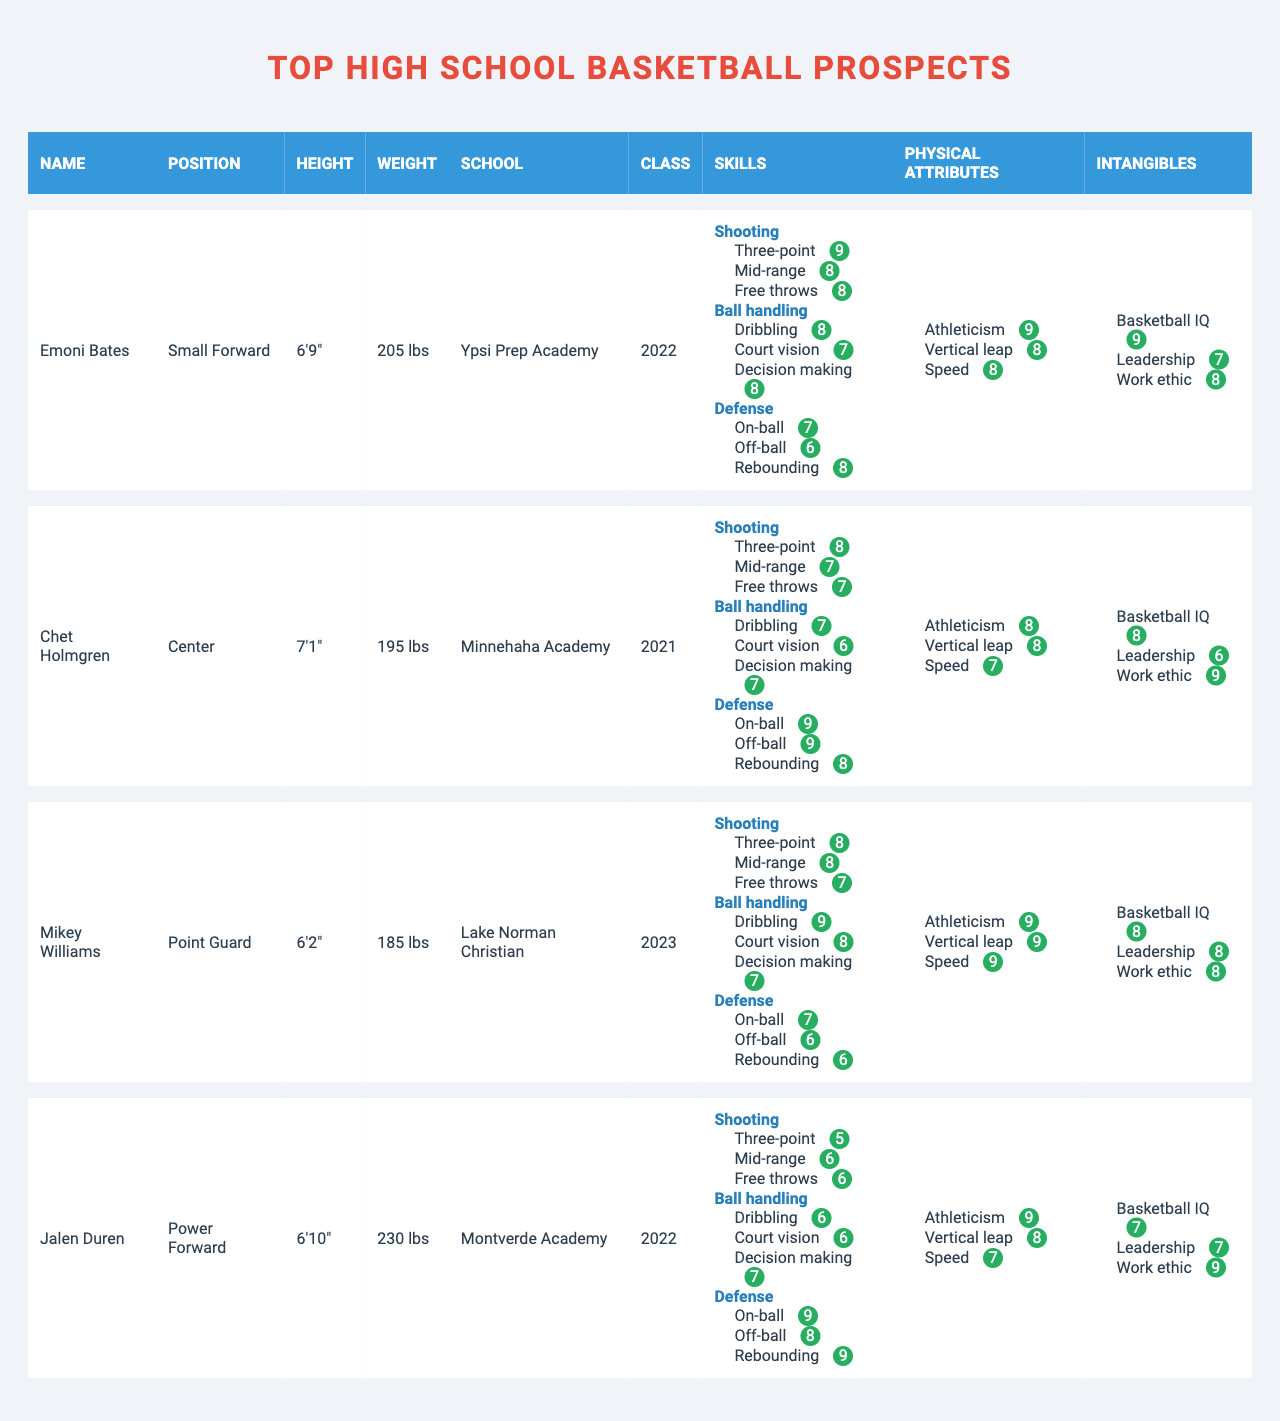What is the height of Emoni Bates? The table lists Emoni Bates under "Name," and his corresponding height is indicated in the "Height" column. It shows that his height is 6'9".
Answer: 6'9" Which player has the highest free throw rating? Looking through the "Free throws" ratings in the "Skills" section, I can see that Emoni Bates and Chet Holmgren both have a rating of 8. This is the highest compared to the other prospects.
Answer: Emoni Bates and Chet Holmgren (rating of 8) What is the average athleticism rating of all players? To find the average, I add the athleticism ratings: Emoni Bates (9) + Chet Holmgren (8) + Mikey Williams (9) + Jalen Duren (9) = 35, and then divide by the number of players (4). This gives an average of 35/4 = 8.75.
Answer: 8.75 Which player has the best on-ball defense rating? In the "Defense" section, I compare the "On-ball" ratings for each player. Chet Holmgren has the highest rating of 9, making him the best in this category.
Answer: Chet Holmgren Does Mikey Williams have a better average rating in physical attributes compared to Jalen Duren? First, I calculate the average physical attributes for both: Mikey Williams has scores of 9, 9, and 9 (Athleticism, Vertical leap, Speed) which averages to 9. Jalen Duren has scores of 9, 8, and 7, averaging to (9 + 8 + 7)/3 = 8. The average for Mikey is higher.
Answer: Yes Which prospect has the lowest mid-range shooting rating, and what is it? The table shows the mid-range shooting ratings for each prospect. Jalen Duren has the lowest rating of 6.
Answer: Jalen Duren, rating of 6 Is it true that all players have a basketball IQ rating of at least 7? I check the "Basketball IQ" ratings and find that all players are rated 7 or higher: Emoni Bates (9), Chet Holmgren (8), Mikey Williams (8), and Jalen Duren (7). Therefore, the statement is true.
Answer: Yes Which player has the highest overall skill assessment in ball handling? I consider the ratings for "Ball handling" from each player: Emoni Bates (23), Chet Holmgren (20), Mikey Williams (24), and Jalen Duren (19). Mikey Williams has the highest score of 24.
Answer: Mikey Williams What is the difference between the three-point shooting ratings of Emoni Bates and Chet Holmgren? Emoni Bates has a three-point shooting rating of 9, and Chet Holmgren has a rating of 8. The difference is calculated as 9 - 8 = 1.
Answer: 1 Which prospect weighs the most, and what is their weight? I look at the "Weight" column and see that Jalen Duren weighs 230 lbs, which is heavier than the others.
Answer: Jalen Duren, 230 lbs Who has the best vertical leap rating among the prospects? I check the "Vertical leap" ratings of each player and find that both Mikey Williams and Emoni Bates have the highest rating of 9.
Answer: Mikey Williams and Emoni Bates (rating of 9) 